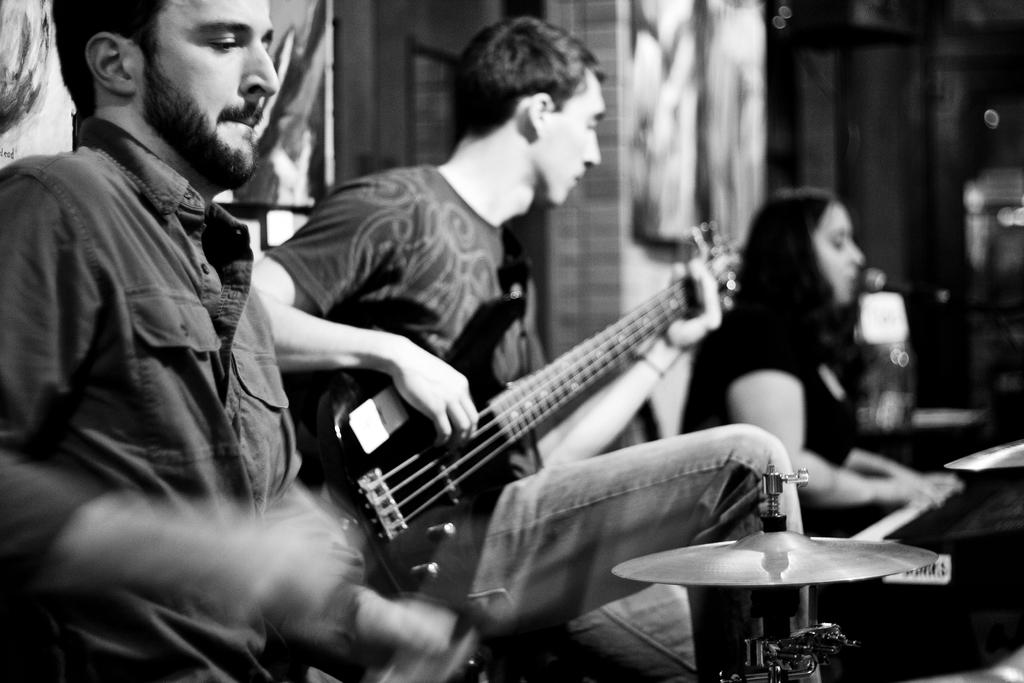What is the person on the left side of the image doing? The person on the left is playing a guitar. Can you describe the person on the right side of the image? There is a woman on the right side of the image. What type of chin can be seen on the woman on the right side of the image? There is no chin visible on the woman in the image, as the image does not show her face. What type of pipe is being played by the person on the left side of the image? There is no pipe present in the image; the person on the left is playing a guitar. 